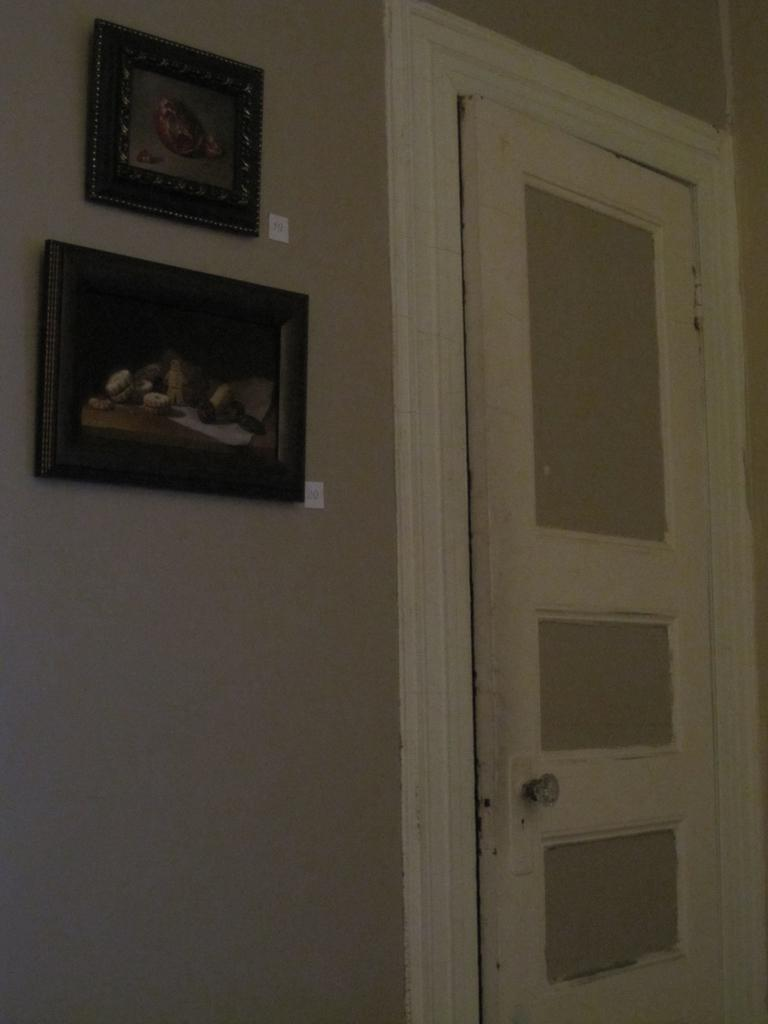What structure is located on the left side of the image? There is a door on the left side of the image. What can be seen on the right side of the image? There are frames attached to the wall on the right side of the image. Where is the hose located in the image? There is no hose present in the image. What type of beef is being cooked on the street in the image? There is no beef or street present in the image. 